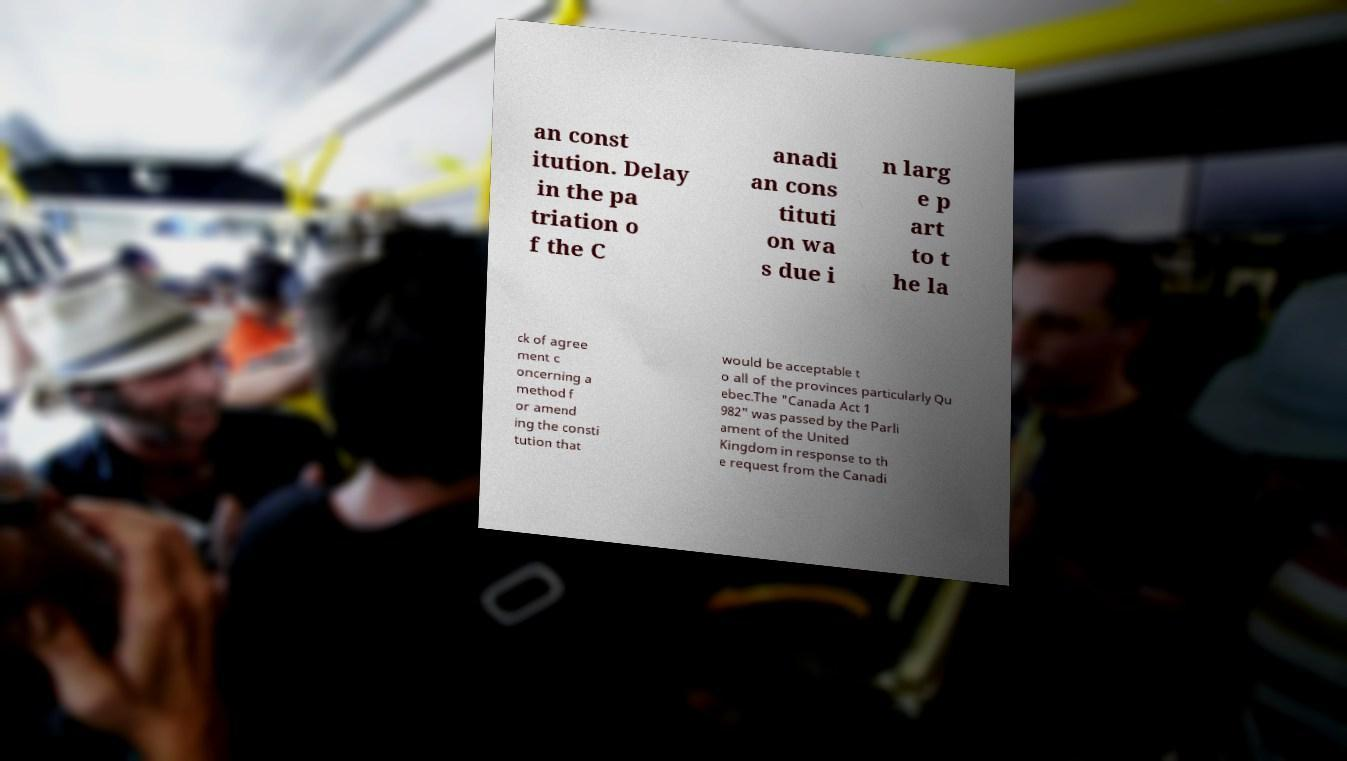Please identify and transcribe the text found in this image. an const itution. Delay in the pa triation o f the C anadi an cons tituti on wa s due i n larg e p art to t he la ck of agree ment c oncerning a method f or amend ing the consti tution that would be acceptable t o all of the provinces particularly Qu ebec.The "Canada Act 1 982" was passed by the Parli ament of the United Kingdom in response to th e request from the Canadi 